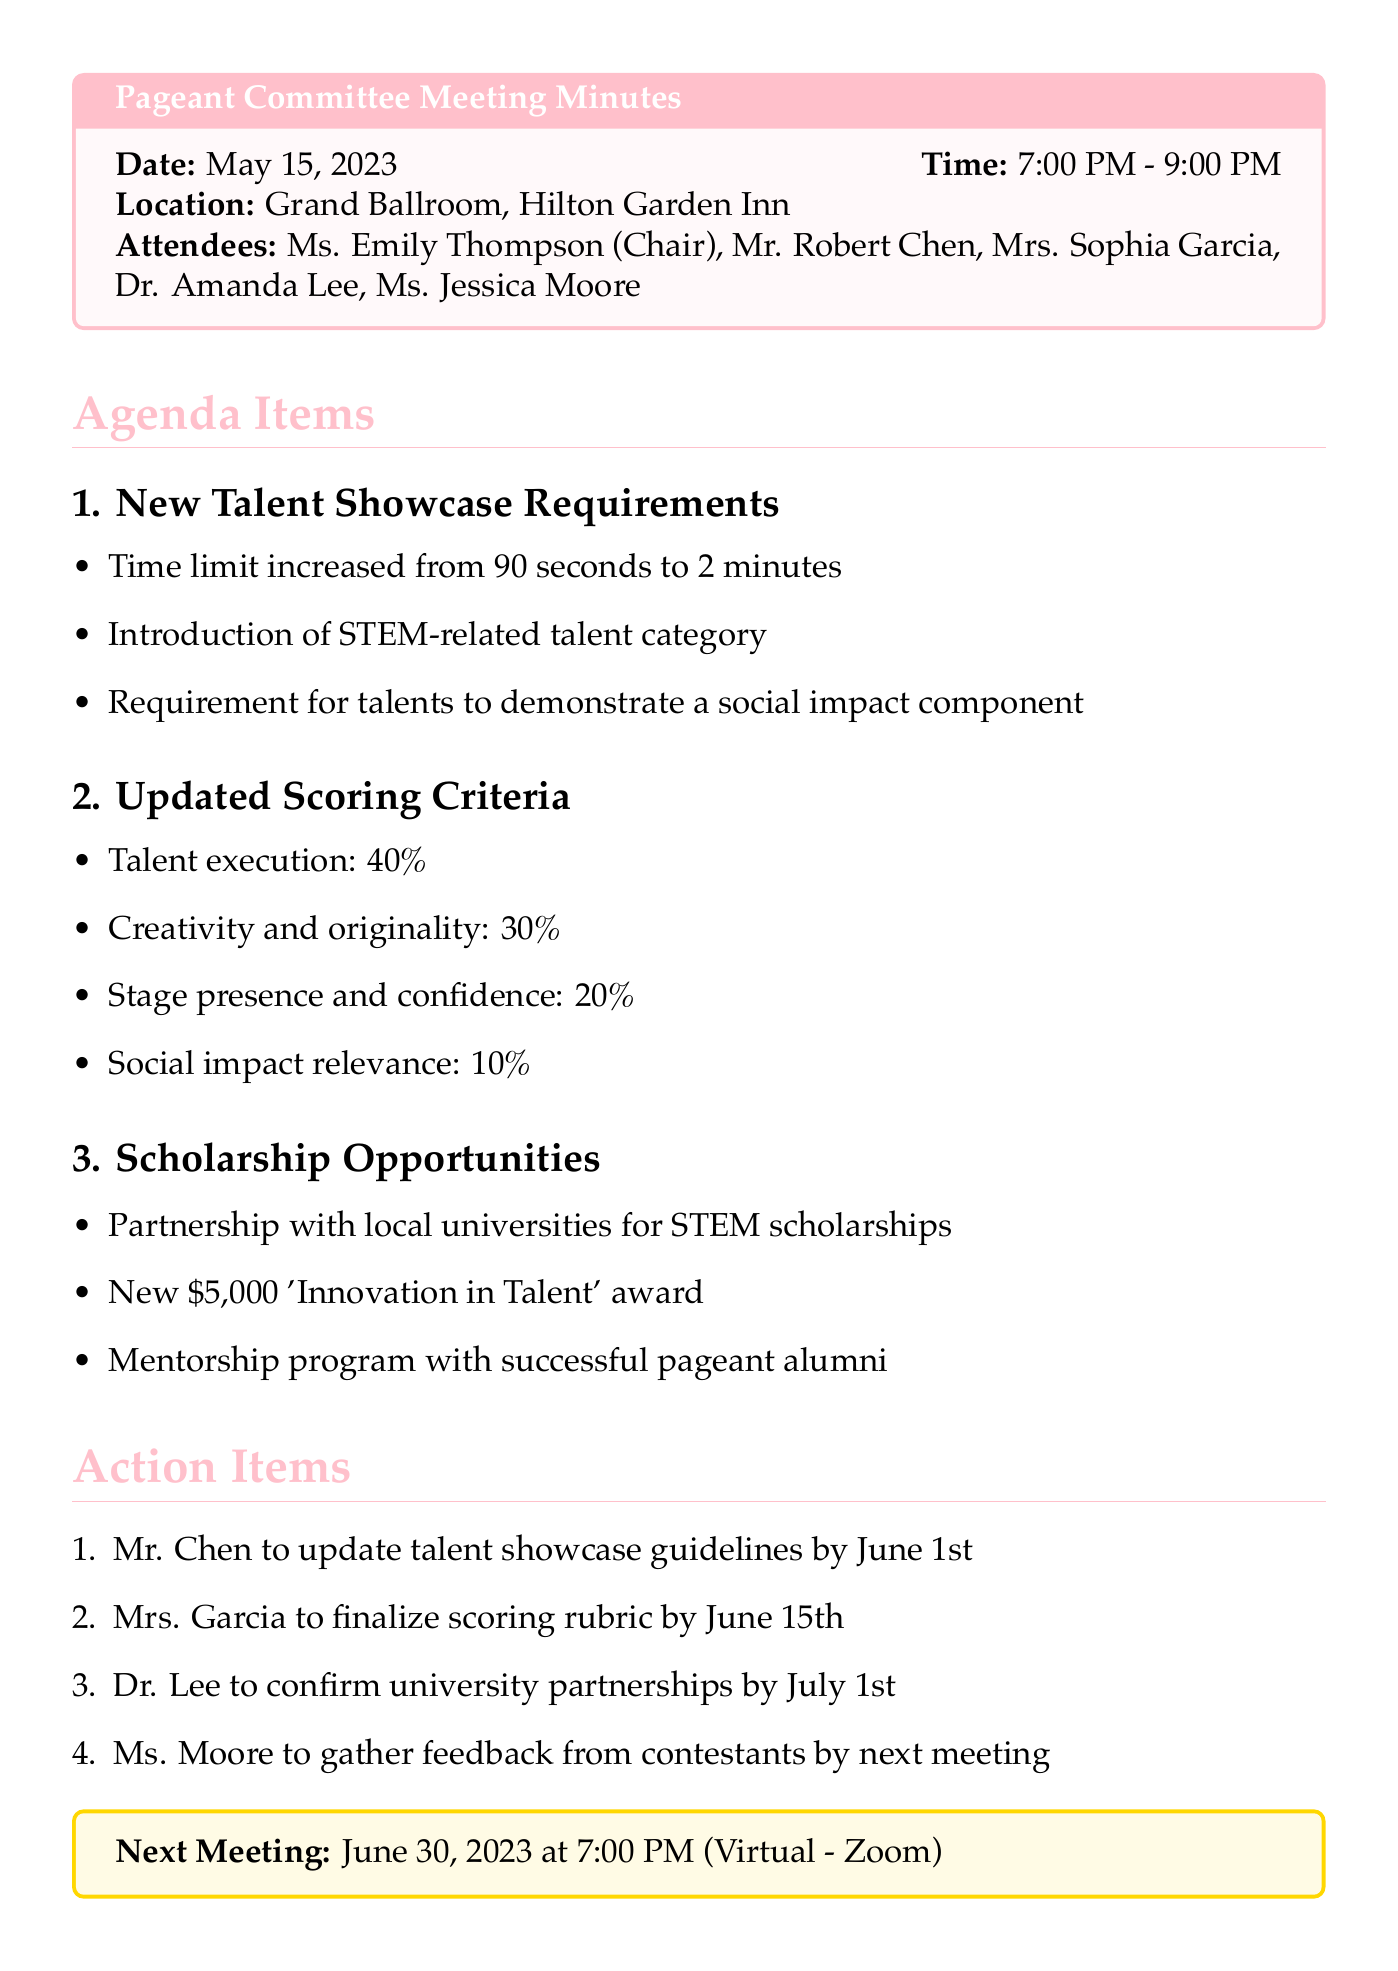What is the date of the meeting? The date of the meeting is mentioned in the document header.
Answer: May 15, 2023 What time did the meeting start? The start time of the meeting is listed alongside the date.
Answer: 7:00 PM Who is the Chair of the committee? The document lists the attendees, including the role and names.
Answer: Ms. Emily Thompson What percentage is assigned to talent execution in the scoring criteria? The scoring criteria section outlines the percentage allocations for each aspect.
Answer: 40% What is the new scholarship amount mentioned in the meeting? The scholarship opportunities section states the amount for the 'Innovation in Talent' award.
Answer: $5,000 When is the next meeting scheduled? The next meeting date and time are mentioned at the end of the document.
Answer: June 30, 2023 What is the main focus of the new talent category introduced? The new category discussed in the meeting highlights a specific area of talent.
Answer: STEM-related talent Who is responsible for finalizing the scoring rubric? The action items section designates responsibilities to specific attendees.
Answer: Mrs. Garcia What is the required demonstration for talents in the new showcase? The requirements for the new talent showcase specify an additional component for performances.
Answer: Social impact component 